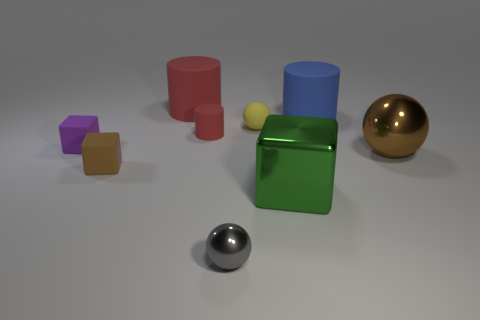Add 1 large yellow objects. How many objects exist? 10 Subtract all balls. How many objects are left? 6 Subtract 0 brown cylinders. How many objects are left? 9 Subtract all big yellow rubber things. Subtract all tiny red cylinders. How many objects are left? 8 Add 7 yellow rubber things. How many yellow rubber things are left? 8 Add 7 large gray matte cylinders. How many large gray matte cylinders exist? 7 